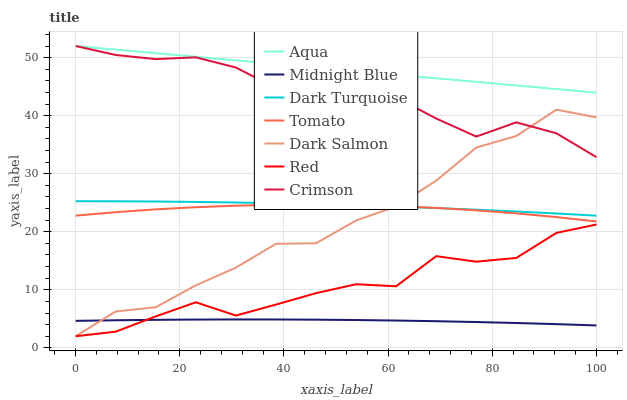Does Midnight Blue have the minimum area under the curve?
Answer yes or no. Yes. Does Aqua have the maximum area under the curve?
Answer yes or no. Yes. Does Dark Turquoise have the minimum area under the curve?
Answer yes or no. No. Does Dark Turquoise have the maximum area under the curve?
Answer yes or no. No. Is Aqua the smoothest?
Answer yes or no. Yes. Is Crimson the roughest?
Answer yes or no. Yes. Is Midnight Blue the smoothest?
Answer yes or no. No. Is Midnight Blue the roughest?
Answer yes or no. No. Does Midnight Blue have the lowest value?
Answer yes or no. No. Does Crimson have the highest value?
Answer yes or no. Yes. Does Dark Turquoise have the highest value?
Answer yes or no. No. Is Dark Turquoise less than Crimson?
Answer yes or no. Yes. Is Crimson greater than Tomato?
Answer yes or no. Yes. Does Dark Salmon intersect Tomato?
Answer yes or no. Yes. Is Dark Salmon less than Tomato?
Answer yes or no. No. Is Dark Salmon greater than Tomato?
Answer yes or no. No. Does Dark Turquoise intersect Crimson?
Answer yes or no. No. 